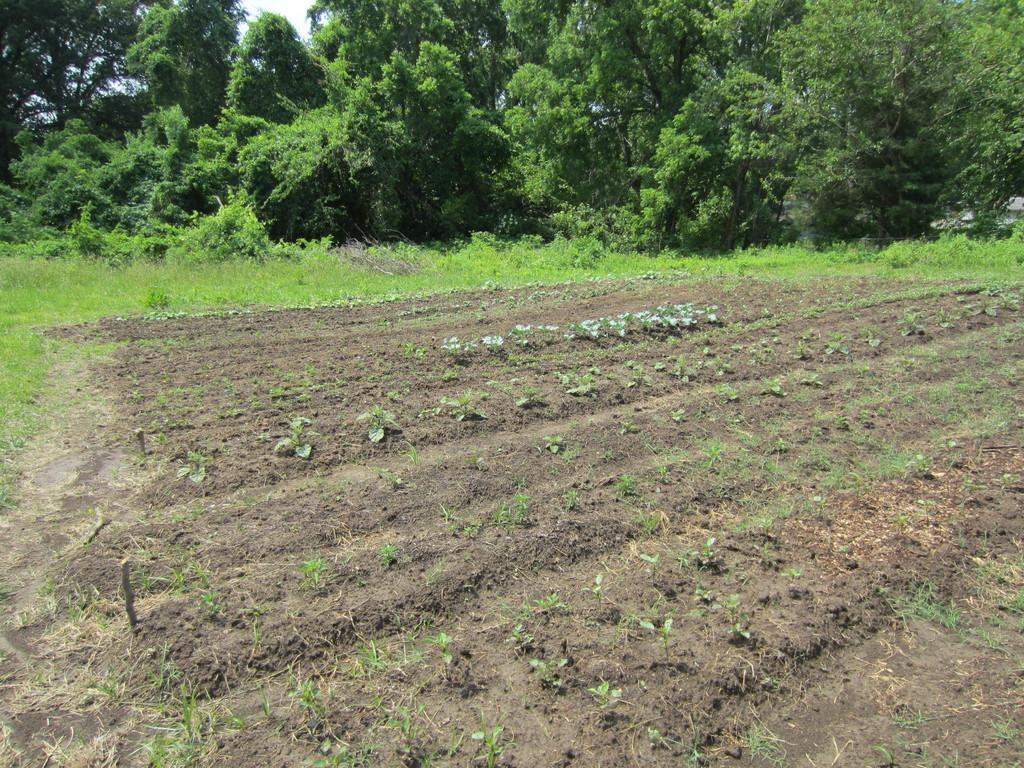What type of surface can be seen in the image? There is ground visible in the image. What is present on the ground in the image? There are plants on the ground. What type of vegetation is visible on the ground? There is grass visible in the image. What can be seen in the background of the image? There are trees and the sky visible in the background of the image. What type of net can be seen in the image? There is no net present in the image. Is there a beast visible in the image? There is no beast present in the image. 